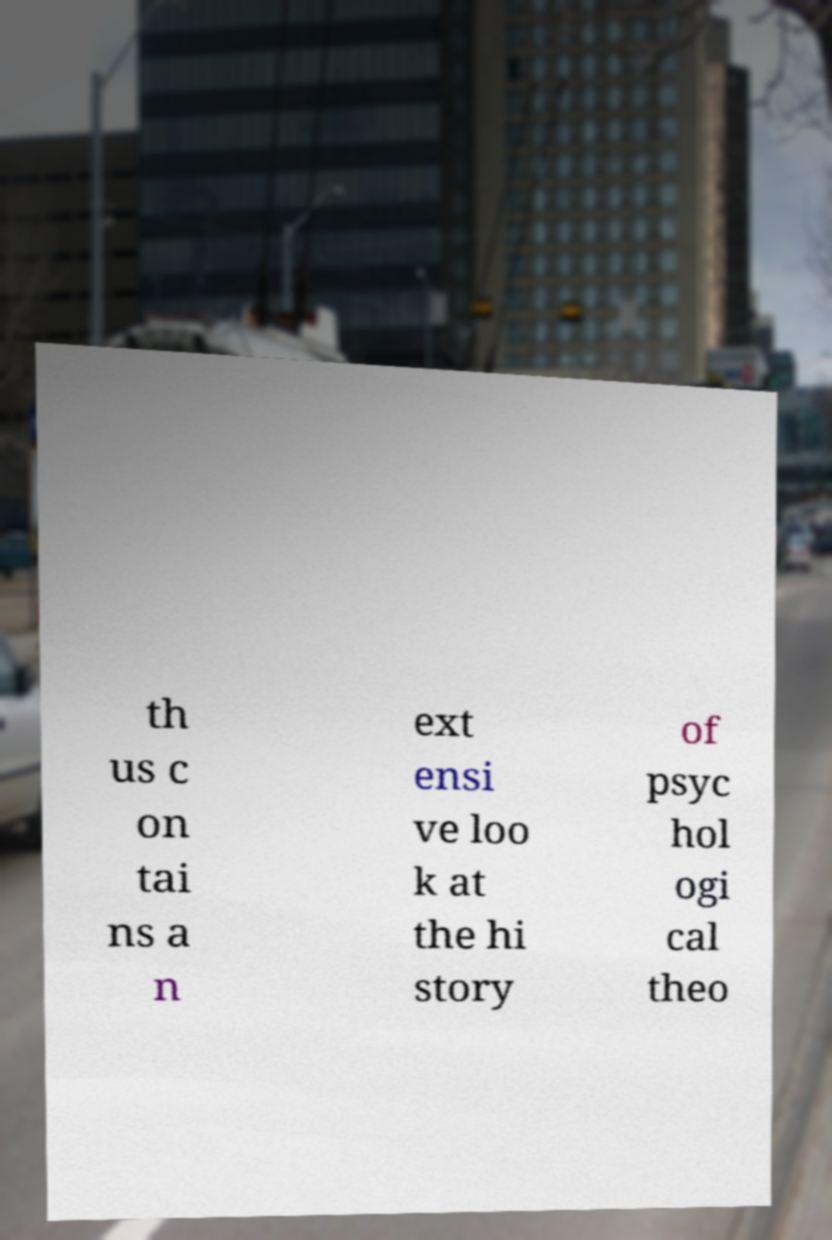Could you extract and type out the text from this image? th us c on tai ns a n ext ensi ve loo k at the hi story of psyc hol ogi cal theo 